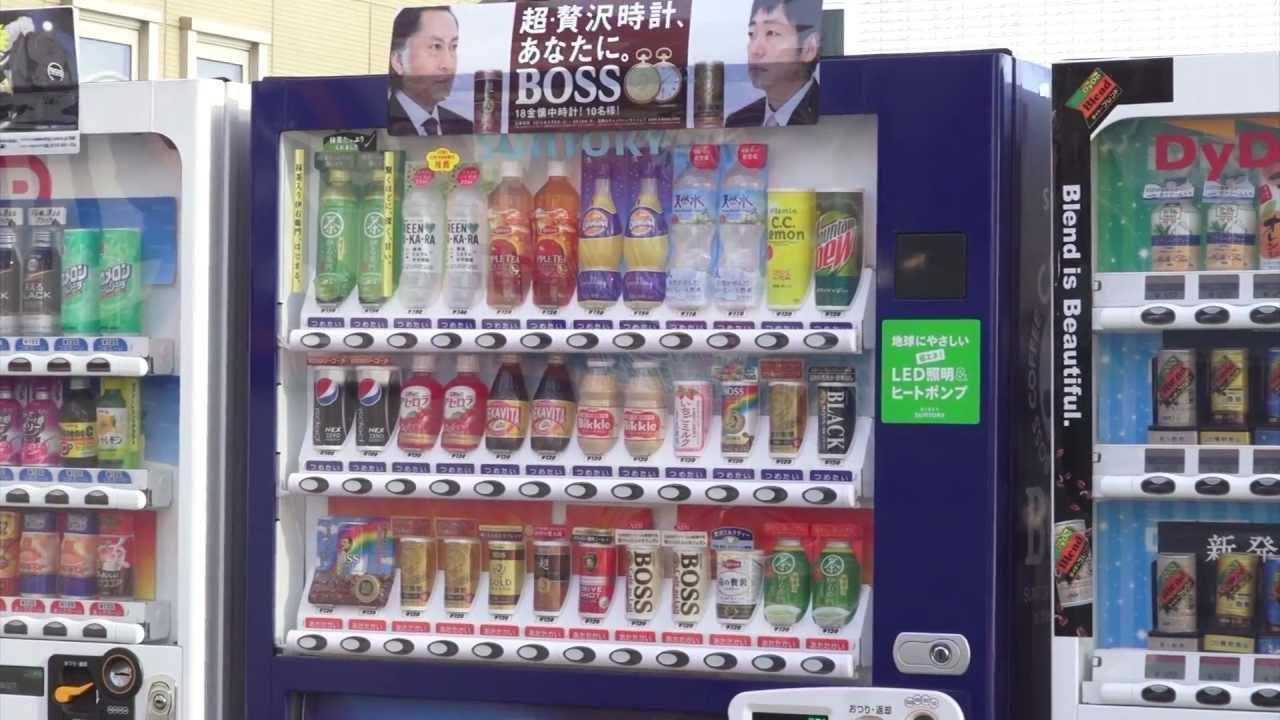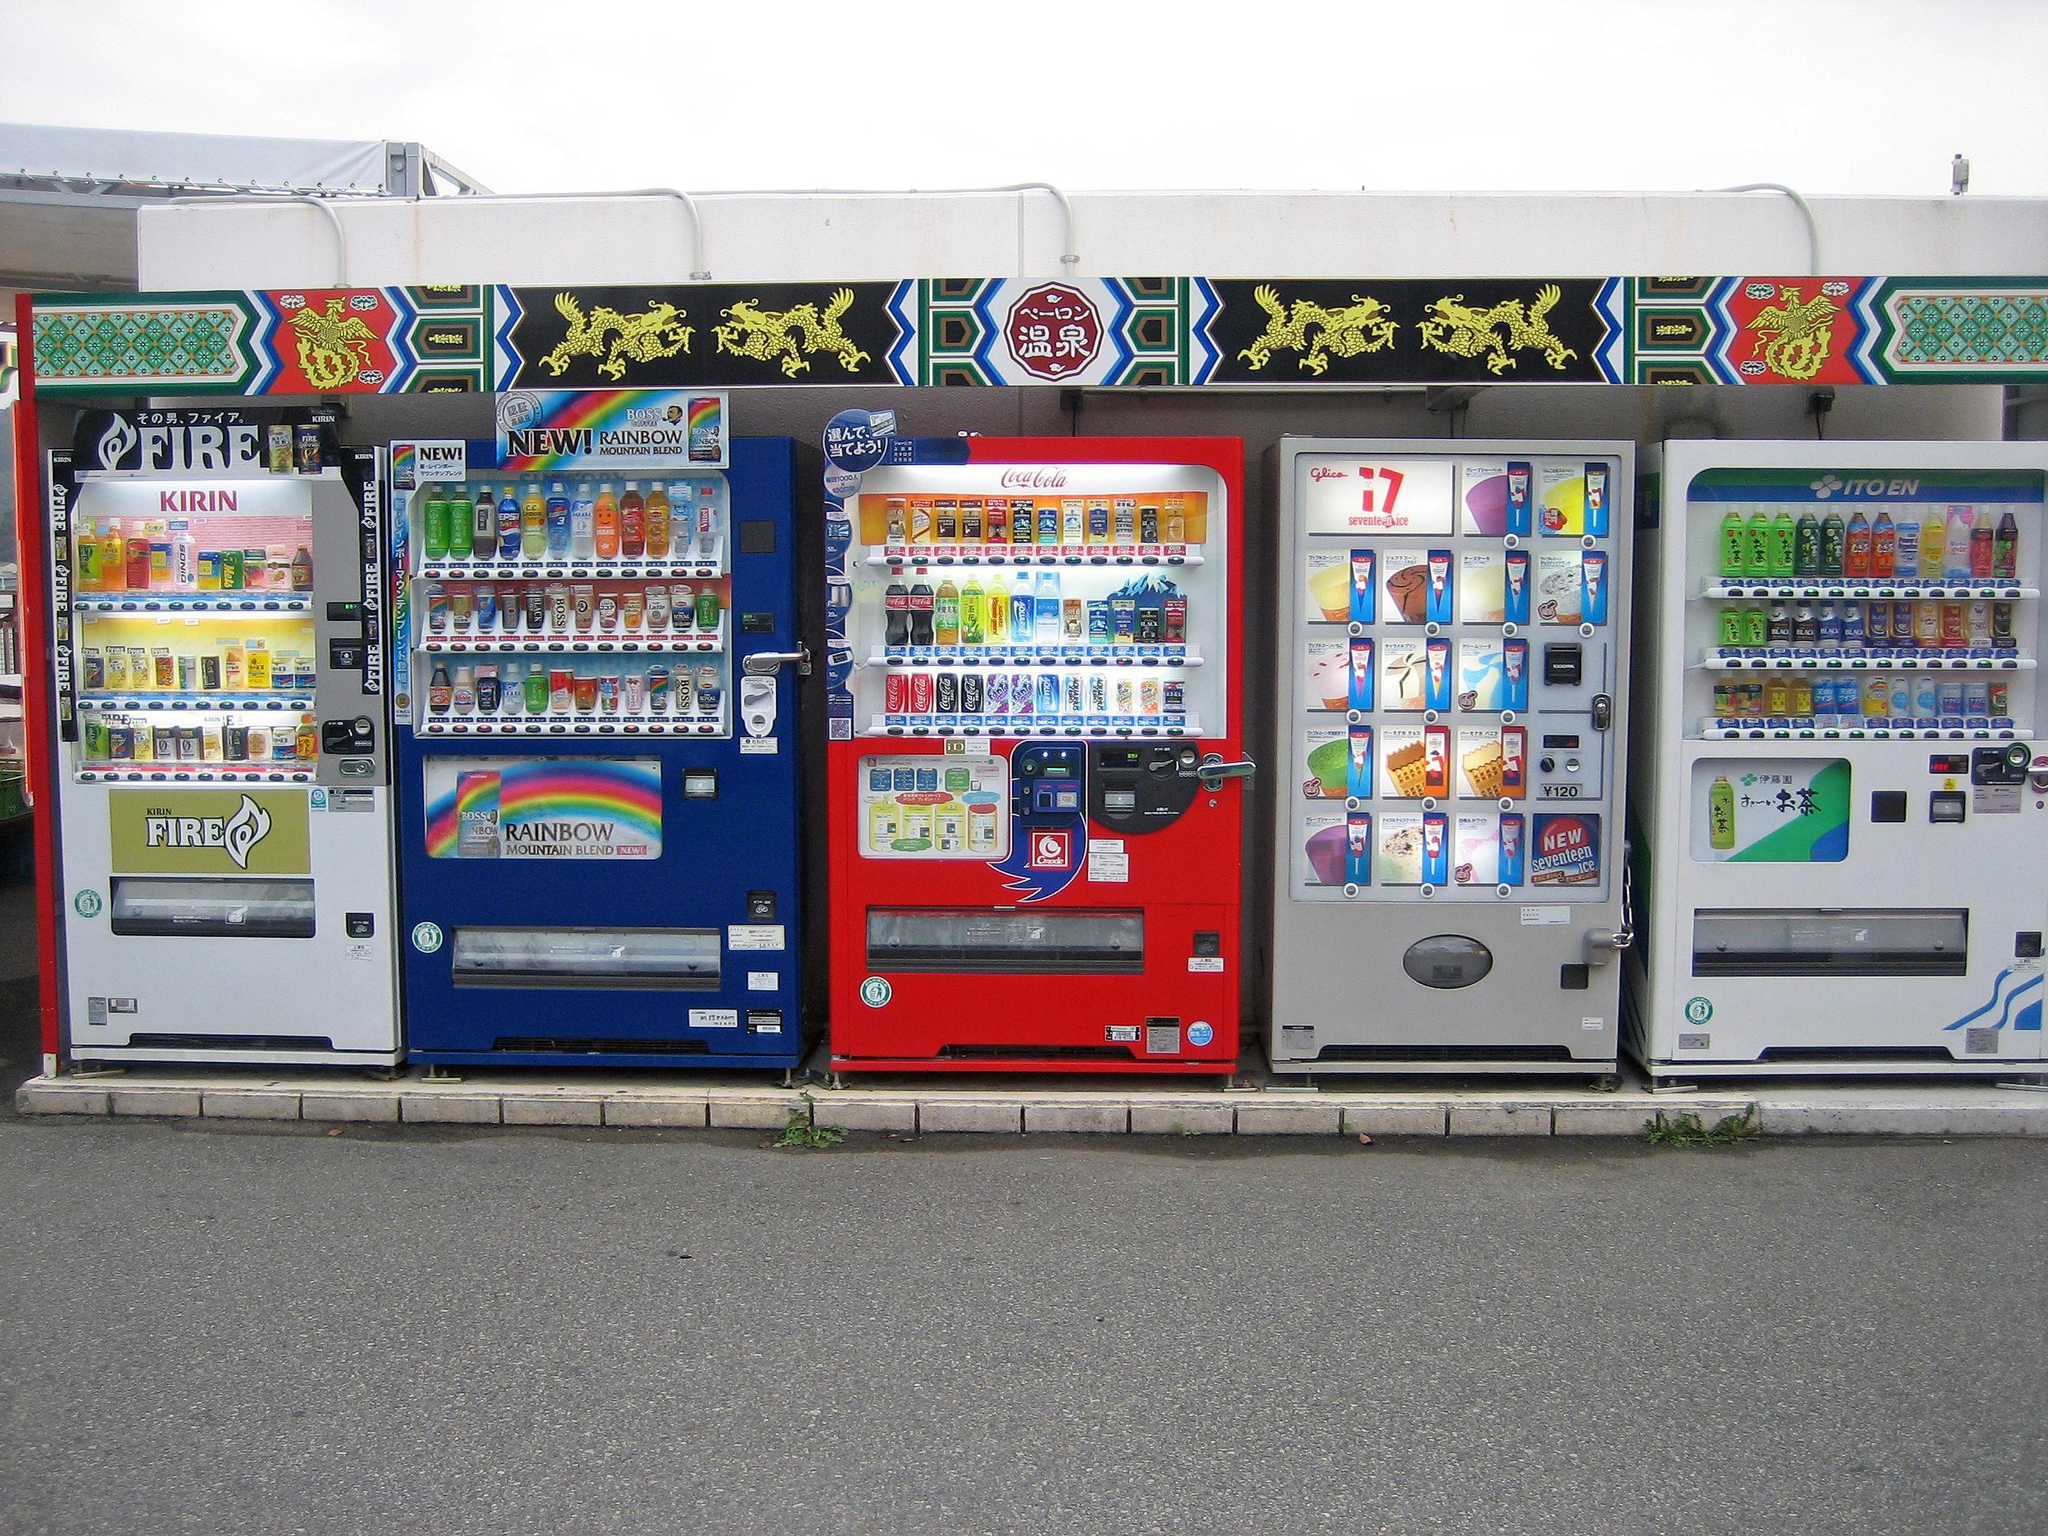The first image is the image on the left, the second image is the image on the right. Examine the images to the left and right. Is the description "One machine is cherry red." accurate? Answer yes or no. Yes. The first image is the image on the left, the second image is the image on the right. For the images displayed, is the sentence "An image shows a single vending machine, which offers meal-type options." factually correct? Answer yes or no. No. 